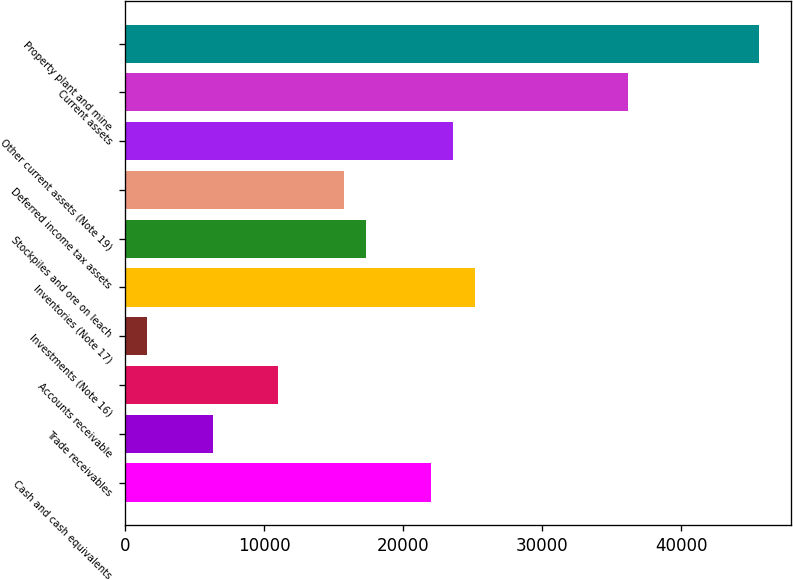Convert chart to OTSL. <chart><loc_0><loc_0><loc_500><loc_500><bar_chart><fcel>Cash and cash equivalents<fcel>Trade receivables<fcel>Accounts receivable<fcel>Investments (Note 16)<fcel>Inventories (Note 17)<fcel>Stockpiles and ore on leach<fcel>Deferred income tax assets<fcel>Other current assets (Note 19)<fcel>Current assets<fcel>Property plant and mine<nl><fcel>22016.2<fcel>6293.2<fcel>11010.1<fcel>1576.3<fcel>25160.8<fcel>17299.3<fcel>15727<fcel>23588.5<fcel>36166.9<fcel>45600.7<nl></chart> 